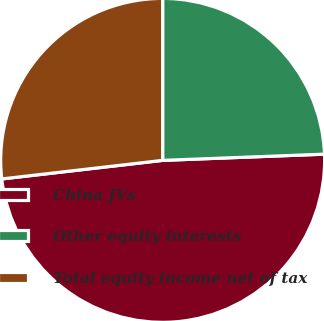<chart> <loc_0><loc_0><loc_500><loc_500><pie_chart><fcel>China JVs<fcel>Other equity interests<fcel>Total equity income net of tax<nl><fcel>48.78%<fcel>24.39%<fcel>26.83%<nl></chart> 